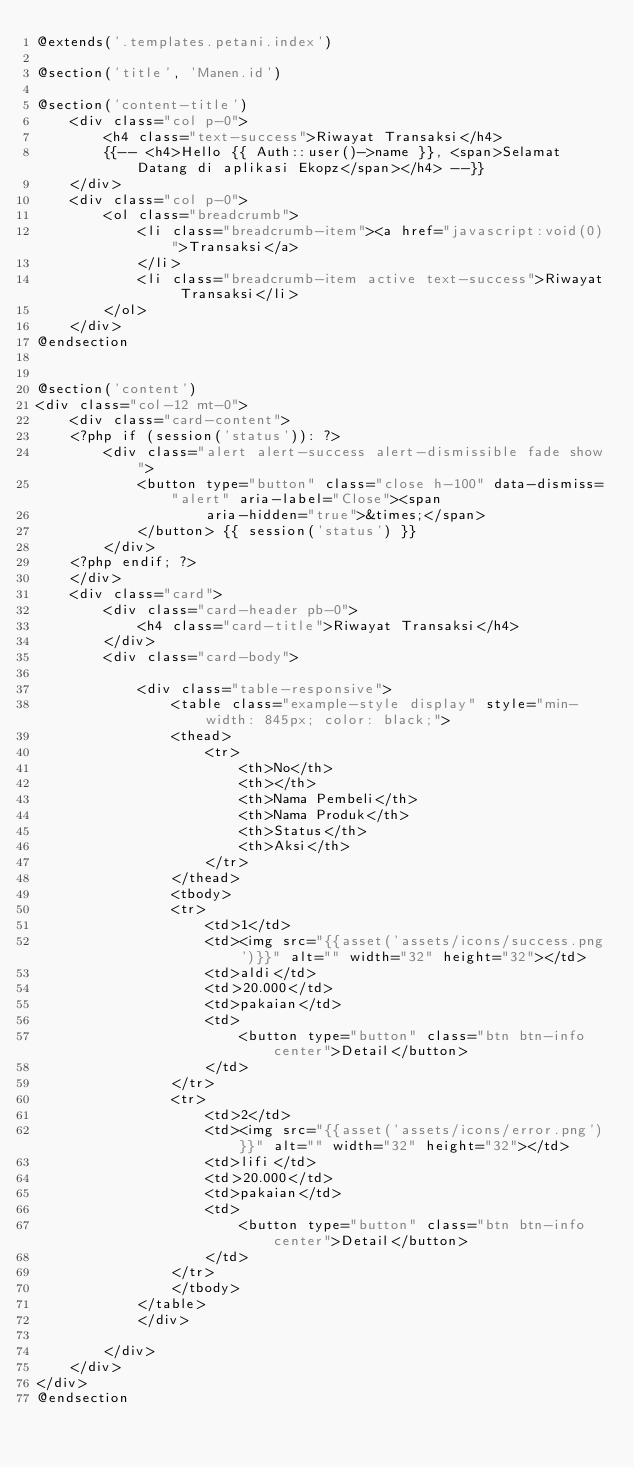Convert code to text. <code><loc_0><loc_0><loc_500><loc_500><_PHP_>@extends('.templates.petani.index')

@section('title', 'Manen.id')

@section('content-title')
    <div class="col p-0">
        <h4 class="text-success">Riwayat Transaksi</h4>
        {{-- <h4>Hello {{ Auth::user()->name }}, <span>Selamat Datang di aplikasi Ekopz</span></h4> --}}
    </div>
    <div class="col p-0">
        <ol class="breadcrumb">
            <li class="breadcrumb-item"><a href="javascript:void(0)">Transaksi</a>
            </li>
            <li class="breadcrumb-item active text-success">Riwayat Transaksi</li>
        </ol>
    </div>
@endsection


@section('content')
<div class="col-12 mt-0">
    <div class="card-content">
    <?php if (session('status')): ?>
        <div class="alert alert-success alert-dismissible fade show">
            <button type="button" class="close h-100" data-dismiss="alert" aria-label="Close"><span
                    aria-hidden="true">&times;</span>
            </button> {{ session('status') }}
        </div>
    <?php endif; ?>
    </div>
    <div class="card">
        <div class="card-header pb-0">
            <h4 class="card-title">Riwayat Transaksi</h4>
        </div>
        <div class="card-body">

            <div class="table-responsive">
                <table class="example-style display" style="min-width: 845px; color: black;">
                <thead>
                    <tr>
                        <th>No</th>
                        <th></th>
                        <th>Nama Pembeli</th>
                        <th>Nama Produk</th>
                        <th>Status</th>
                        <th>Aksi</th>
                    </tr>
                </thead>
                <tbody>
                <tr>
                    <td>1</td>
                    <td><img src="{{asset('assets/icons/success.png')}}" alt="" width="32" height="32"></td>
                    <td>aldi</td>
                    <td>20.000</td>
                    <td>pakaian</td>
                    <td>
                        <button type="button" class="btn btn-info center">Detail</button>
                    </td>
                </tr>
                <tr>
                    <td>2</td>
                    <td><img src="{{asset('assets/icons/error.png')}}" alt="" width="32" height="32"></td>
                    <td>lifi</td>
                    <td>20.000</td>
                    <td>pakaian</td>
                    <td>
                        <button type="button" class="btn btn-info center">Detail</button>
                    </td>
                </tr>
                </tbody>
            </table>
            </div>

        </div>
    </div>
</div>
@endsection</code> 